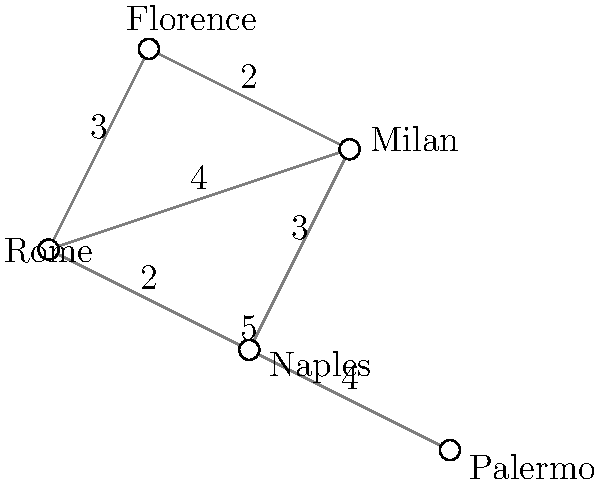As an aspiring athlete, you need to visit multiple training facilities across Italy. The graph represents five major cities with training centers, where the edges show direct connections between cities, and the numbers on the edges represent travel time in hours. Starting from Rome, what is the shortest time needed to visit all cities and return to Rome (known as the Traveling Salesman Problem)? To solve this Traveling Salesman Problem, we need to find the shortest Hamiltonian cycle starting and ending in Rome. Let's approach this step-by-step:

1) First, list all possible routes starting and ending in Rome that visit each city once:
   
   Route 1: Rome -> Florence -> Milan -> Naples -> Palermo -> Rome
   Route 2: Rome -> Florence -> Milan -> Palermo -> Naples -> Rome
   Route 3: Rome -> Milan -> Florence -> Naples -> Palermo -> Rome
   Route 4: Rome -> Milan -> Florence -> Palermo -> Naples -> Rome
   Route 5: Rome -> Naples -> Florence -> Milan -> Palermo -> Rome
   Route 6: Rome -> Naples -> Palermo -> Milan -> Florence -> Rome
   Route 7: Rome -> Palermo -> Naples -> Florence -> Milan -> Rome
   Route 8: Rome -> Palermo -> Naples -> Milan -> Florence -> Rome

2) Now, calculate the total time for each route:

   Route 1: 3 + 2 + 3 + 4 + 5 = 17 hours
   Route 2: 3 + 2 + (4 + 4) + 2 = 15 hours
   Route 3: 4 + 2 + 3 + 4 + 5 = 18 hours
   Route 4: 4 + 2 + (4 + 4) + 2 = 16 hours
   Route 5: 2 + 3 + 2 + (4 + 4) = 15 hours
   Route 6: 2 + 4 + (4 + 4) + 3 = 17 hours
   Route 7: 5 + 4 + 3 + 2 + 4 = 18 hours
   Route 8: 5 + 4 + 3 + 2 + 3 = 17 hours

3) The shortest routes are Route 2 and Route 5, both taking 15 hours.

Therefore, the shortest time needed to visit all cities and return to Rome is 15 hours.
Answer: 15 hours 